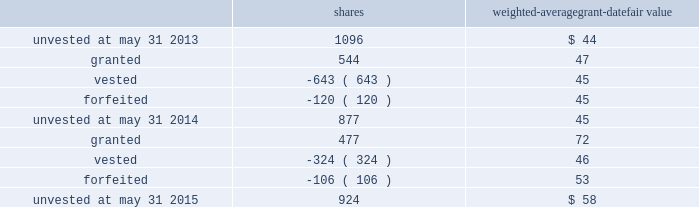The performance units granted to certain executives in fiscal 2014 were based on a one-year performance period .
After the compensation committee certified the performance results , 25% ( 25 % ) of the performance units converted to unrestricted shares .
The remaining 75% ( 75 % ) converted to restricted shares that vest in equal installments on each of the first three anniversaries of the conversion date .
The performance units granted to certain executives during fiscal 2015 were based on a three-year performance period .
After the compensation committee certifies the performance results for the three-year period , performance units earned will convert into unrestricted common stock .
The compensation committee may set a range of possible performance-based outcomes for performance units .
Depending on the achievement of the performance measures , the grantee may earn up to 200% ( 200 % ) of the target number of shares .
For awards with only performance conditions , we recognize compensation expense over the performance period using the grant date fair value of the award , which is based on the number of shares expected to be earned according to the level of achievement of performance goals .
If the number of shares expected to be earned were to change at any time during the performance period , we would make a cumulative adjustment to share-based compensation expense based on the revised number of shares expected to be earned .
During fiscal 2015 , certain executives were granted performance units that we refer to as leveraged performance units , or lpus .
Lpus contain a market condition based on our relative stock price growth over a three-year performance period .
The lpus contain a minimum threshold performance which , if not met , would result in no payout .
The lpus also contain a maximum award opportunity set as a fixed dollar and fixed number of shares .
After the three-year performance period , one-third of any earned units converts to unrestricted common stock .
The remaining two-thirds convert to restricted stock that will vest in equal installments on each of the first two anniversaries of the conversion date .
We recognize share-based compensation expense based on the grant date fair value of the lpus , as determined by use of a monte carlo model , on a straight-line basis over the requisite service period for each separately vesting portion of the lpu award .
Total shareholder return units before fiscal 2015 , certain of our executives were granted total shareholder return ( 201ctsr 201d ) units , which are performance-based restricted stock units that are earned based on our total shareholder return over a three-year performance period compared to companies in the s&p 500 .
Once the performance results are certified , tsr units convert into unrestricted common stock .
Depending on our performance , the grantee may earn up to 200% ( 200 % ) of the target number of shares .
The target number of tsr units for each executive is set by the compensation committee .
We recognize share-based compensation expense based on the grant date fair value of the tsr units , as determined by use of a monte carlo model , on a straight-line basis over the vesting period .
The table summarizes the changes in unvested share-based awards for the years ended may 31 , 2015 and 2014 ( shares in thousands ) : shares weighted-average grant-date fair value .
Global payments inc .
| 2015 form 10-k annual report 2013 81 .
What is the total amount of unvested shares gifted by the company during the three year period? 
Rationale: to find out the total amount of unvested shares the company one must added up the shares given by the company over the course of the three years .
Computations: ((1096 + 877) + 924)
Answer: 2897.0. 